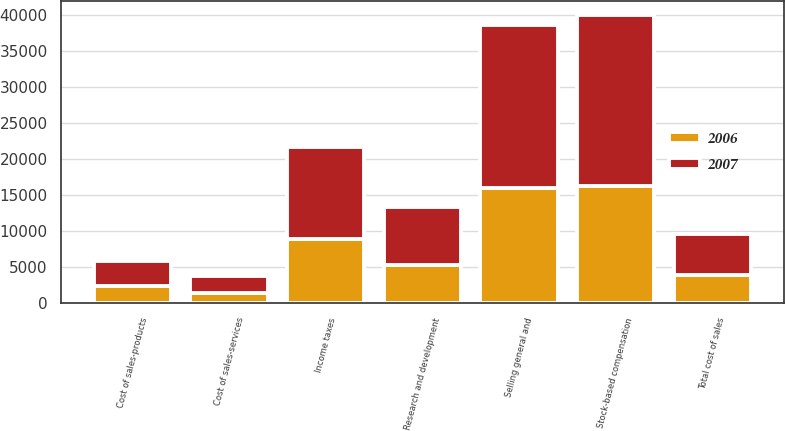Convert chart. <chart><loc_0><loc_0><loc_500><loc_500><stacked_bar_chart><ecel><fcel>Cost of sales-products<fcel>Cost of sales-services<fcel>Total cost of sales<fcel>Selling general and<fcel>Research and development<fcel>Stock-based compensation<fcel>Income taxes<nl><fcel>2007<fcel>3472<fcel>2276<fcel>5748<fcel>22560<fcel>7984<fcel>23641<fcel>12651<nl><fcel>2006<fcel>2417<fcel>1452<fcel>3869<fcel>16037<fcel>5354<fcel>16298<fcel>8962<nl></chart> 